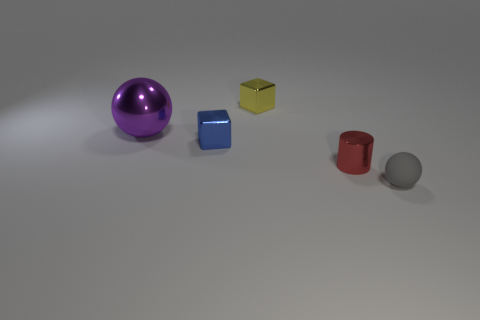Add 1 small yellow metallic objects. How many objects exist? 6 Subtract all cubes. How many objects are left? 3 Subtract 0 blue spheres. How many objects are left? 5 Subtract all red metal objects. Subtract all large yellow balls. How many objects are left? 4 Add 4 purple things. How many purple things are left? 5 Add 5 tiny red shiny cylinders. How many tiny red shiny cylinders exist? 6 